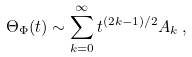Convert formula to latex. <formula><loc_0><loc_0><loc_500><loc_500>\Theta _ { \Phi } ( t ) \sim \sum _ { k = 0 } ^ { \infty } t ^ { ( 2 k - 1 ) / 2 } A _ { k } \, ,</formula> 